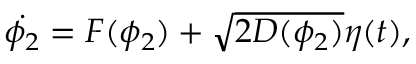Convert formula to latex. <formula><loc_0><loc_0><loc_500><loc_500>\dot { \phi _ { 2 } } = F ( \phi _ { 2 } ) + \sqrt { 2 D ( \phi _ { 2 } ) } \eta ( t ) ,</formula> 